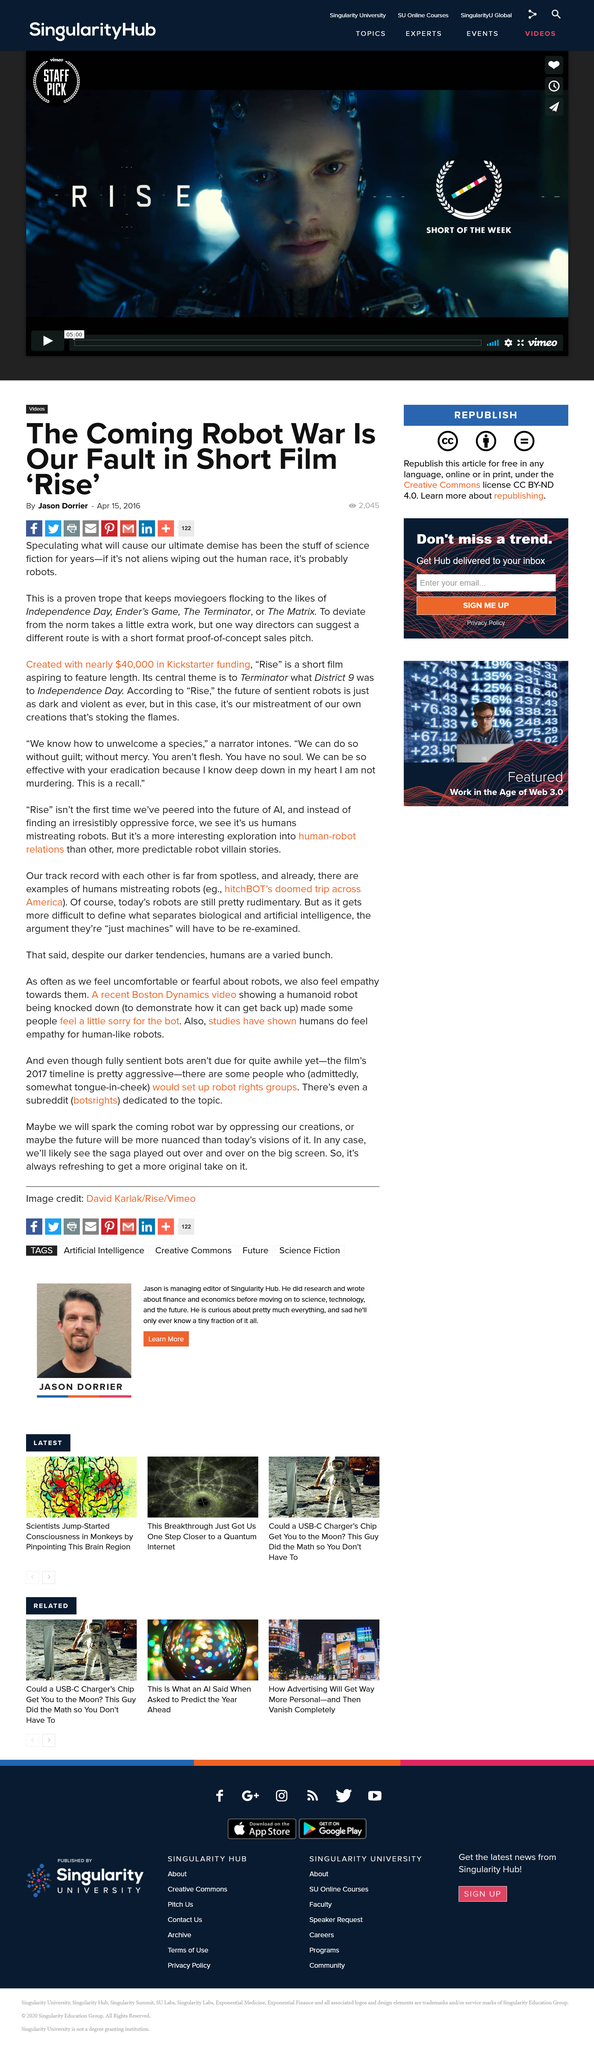Indicate a few pertinent items in this graphic. The film 'Rise' was funded with $40,000 in Kickstarter funding. This article has been viewed by 2,045 people. 